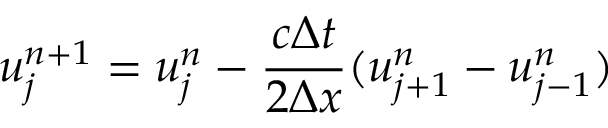Convert formula to latex. <formula><loc_0><loc_0><loc_500><loc_500>u _ { j } ^ { n + 1 } = u _ { j } ^ { n } - \frac { c \Delta t } { 2 \Delta x } ( u _ { j + 1 } ^ { n } - u _ { j - 1 } ^ { n } )</formula> 